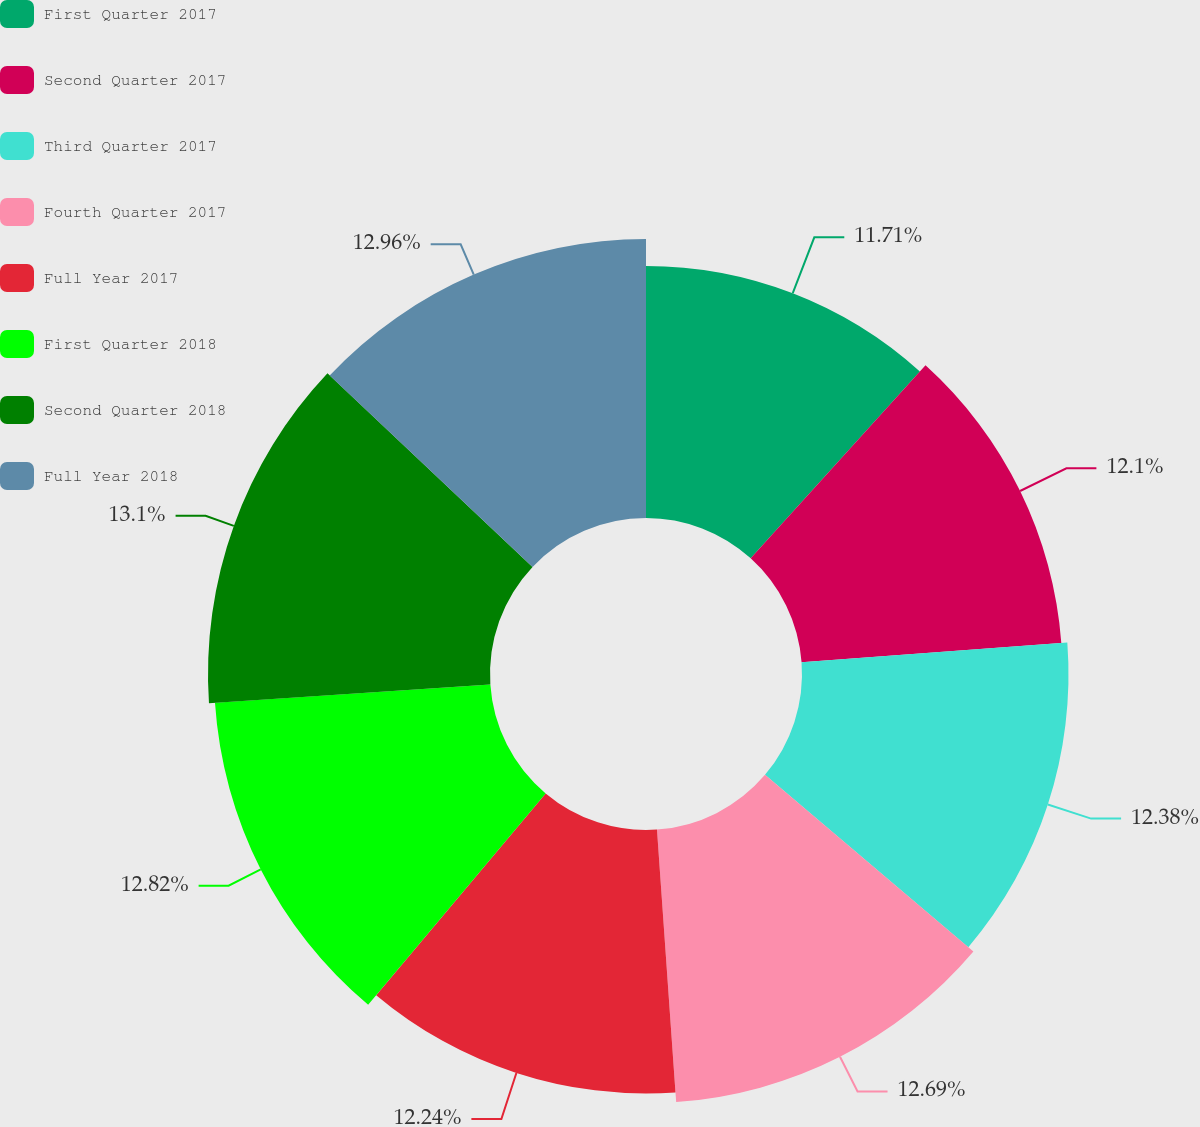<chart> <loc_0><loc_0><loc_500><loc_500><pie_chart><fcel>First Quarter 2017<fcel>Second Quarter 2017<fcel>Third Quarter 2017<fcel>Fourth Quarter 2017<fcel>Full Year 2017<fcel>First Quarter 2018<fcel>Second Quarter 2018<fcel>Full Year 2018<nl><fcel>11.71%<fcel>12.1%<fcel>12.38%<fcel>12.69%<fcel>12.24%<fcel>12.82%<fcel>13.1%<fcel>12.96%<nl></chart> 